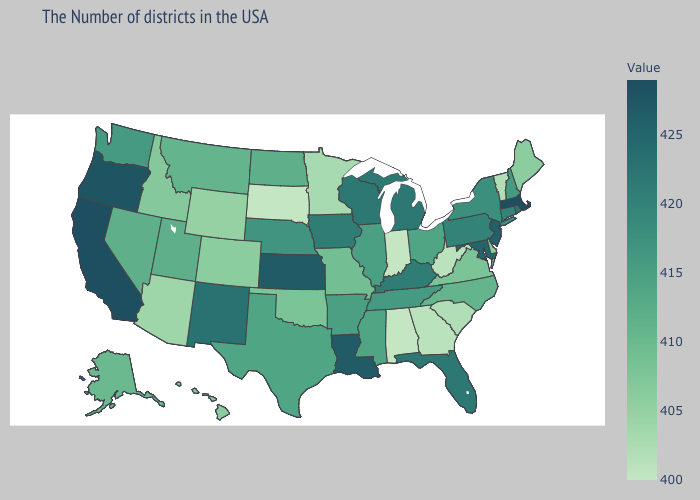Which states have the lowest value in the West?
Quick response, please. Arizona. Does Missouri have a higher value than Oregon?
Short answer required. No. Does Montana have a lower value than Ohio?
Be succinct. Yes. Does Maine have the highest value in the USA?
Write a very short answer. No. Among the states that border Wyoming , which have the highest value?
Keep it brief. Nebraska. 